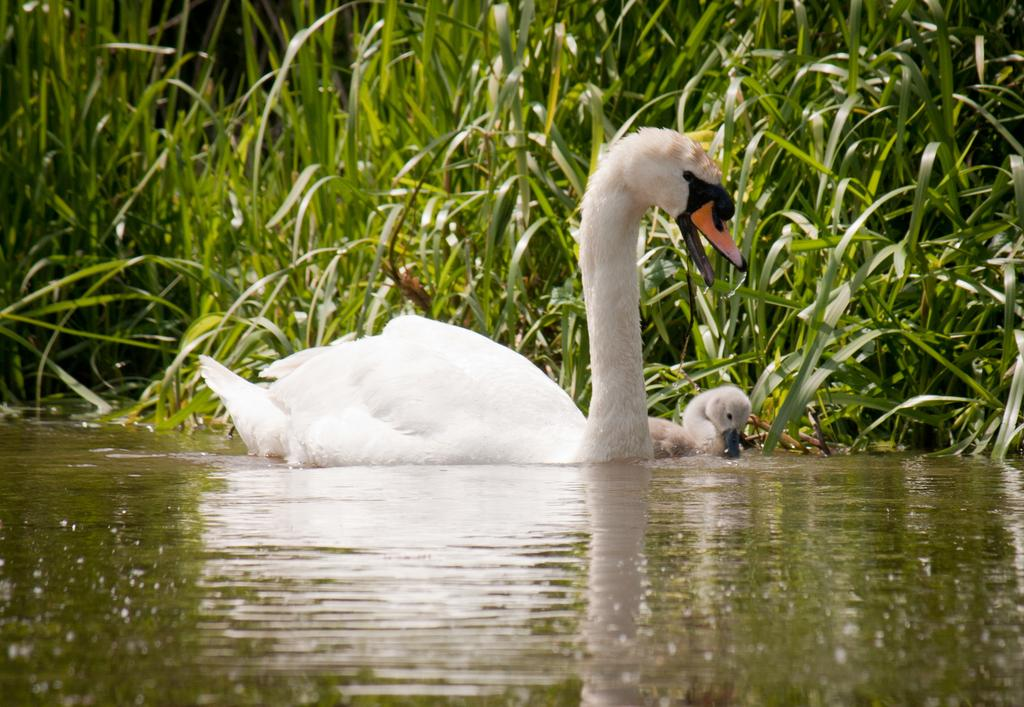What is in the front of the image? There is water in the front of the image. What can be seen in the water in the center of the image? There are birds in the water in the center of the image. What is visible in the background of the image? There are plants in the background of the image. Where is the machine located in the image? There is no machine present in the image. Can you see a cow swimming with the birds in the water? There is no cow present in the image; only birds can be seen in the water. 